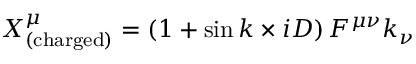<formula> <loc_0><loc_0><loc_500><loc_500>X _ { ( c h \arg e d ) } ^ { \mu } = \left ( 1 + \sin { k \times i D } \right ) F ^ { \mu \nu } k _ { \nu }</formula> 